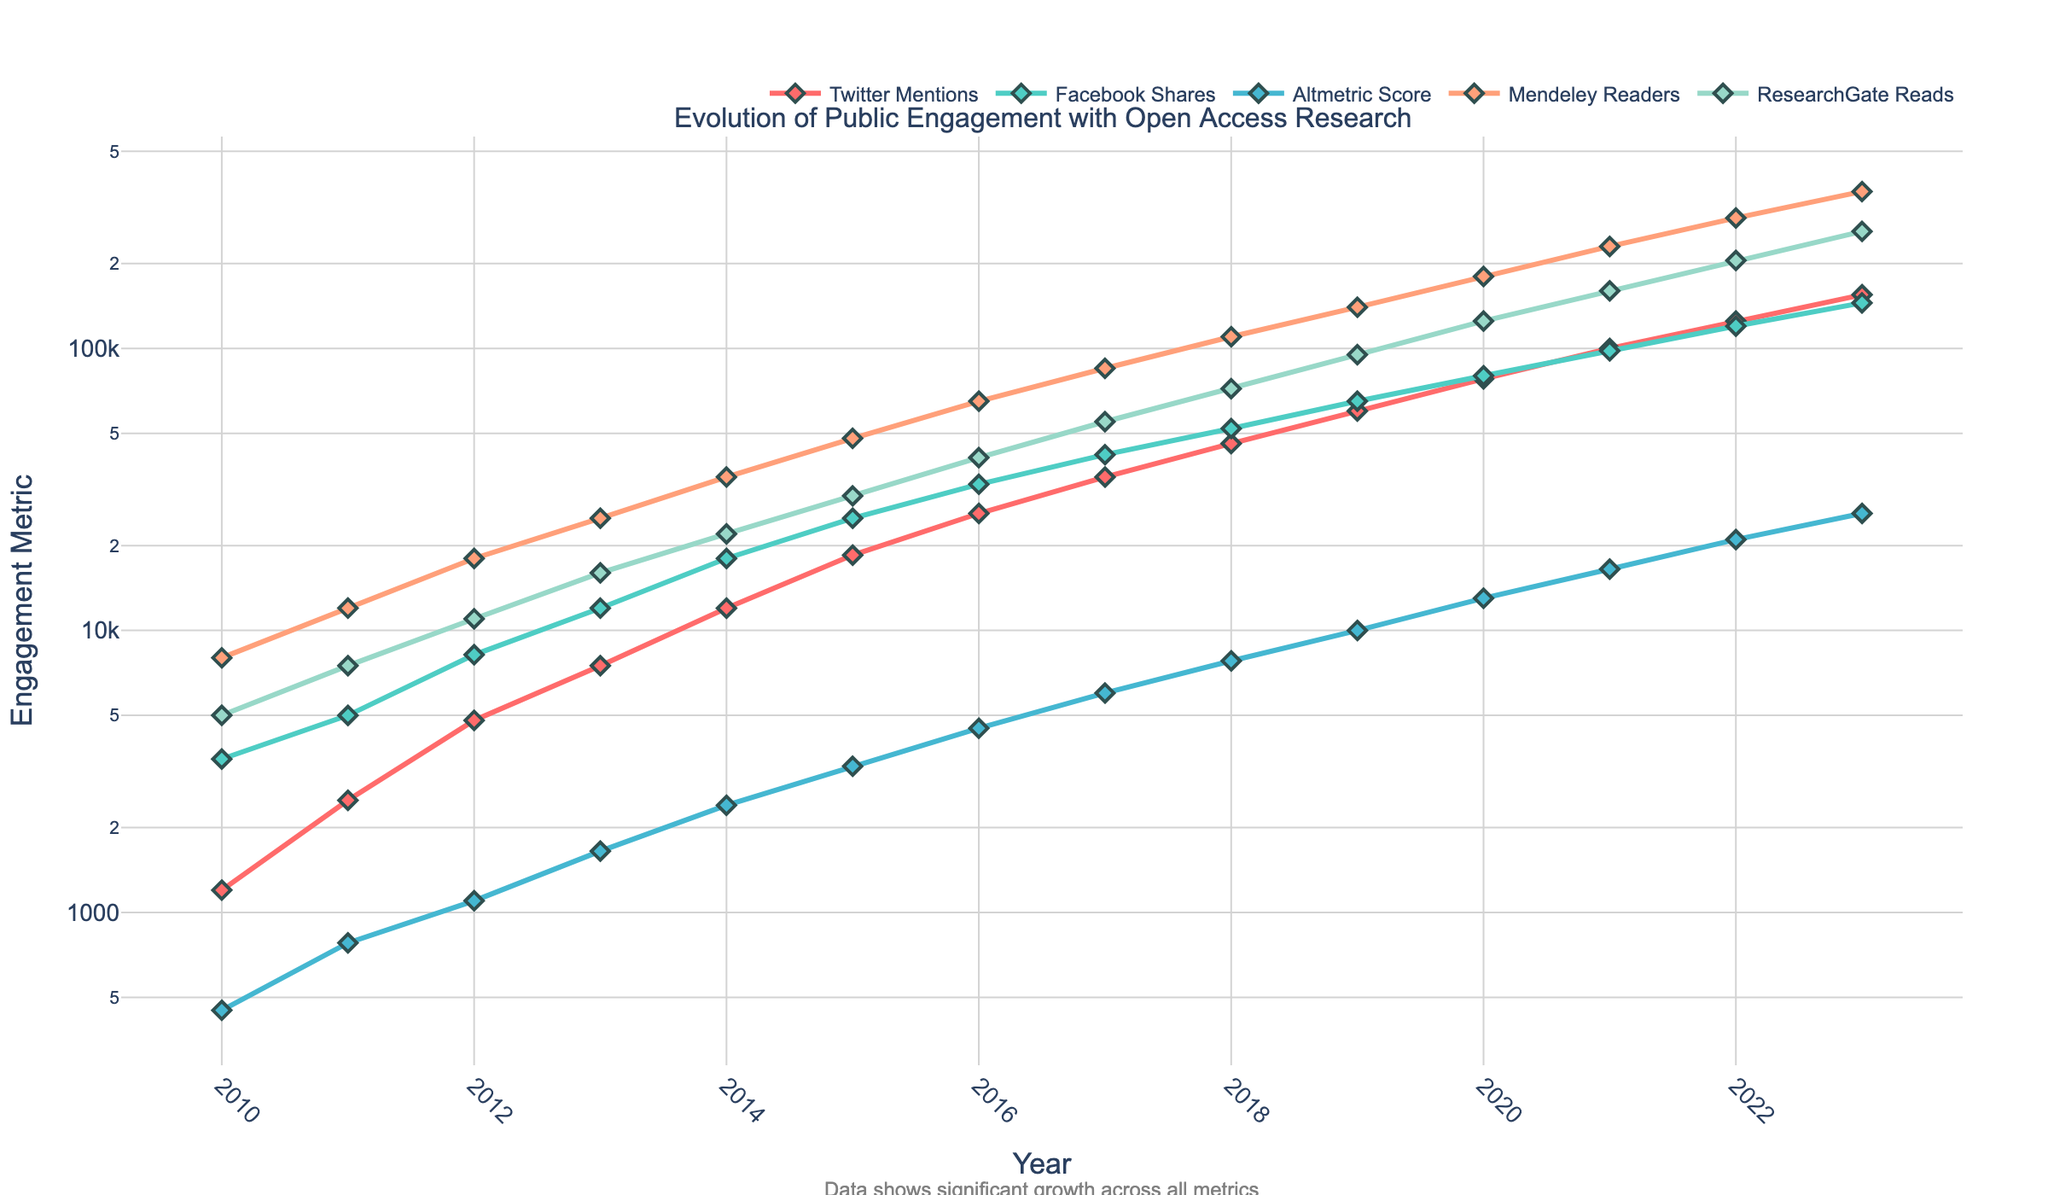What was the change in the number of Twitter mentions from 2010 to 2023? To find the change, subtract the number of Twitter mentions in 2010 from the number in 2023: 155,000 (2023) - 1,200 (2010) = 153,800
Answer: 153,800 Which platform saw the highest increase in engagement from 2010 to 2023? Examine the data for each platform's first and last year to determine the highest increase. For Twitter mentions: 155,000 - 1,200 = 153,800; For Facebook shares: 145,000 - 3,500 = 141,500; For Altmetric score: 26,000 - 450 = 25,550; For Mendeley readers: 360,000 - 8,000 = 352,000; For ResearchGate reads: 260,000 - 5,000 = 255,000. Hence, Mendeley readers saw the highest increase.
Answer: Mendeley readers Between which years did Altmetric scores show the most significant increase? To identify the steepest increase, look at the difference in Altmetric scores between consecutive years. The largest change occurred from 2022 to 2023: 26,000 (2023) - 21,000 (2022) = 5,000
Answer: 2022 to 2023 What is the average number of Facebook shares over the years? Sum all Facebook shares from 2010 to 2023 and divide by the number of years: (3,500 + 5,000 + 8,200 + 12,000 + 18,000 + 25,000 + 33,000 + 42,000 + 52,000 + 65,000 + 80,000 + 98,000 + 120,000 + 145,000) / 14 ≈ 49,485.71
Answer: 49,485.71 How does the trend of ResearchGate reads compare with Mendeley readers over the years? To compare the trends, observe the overall pattern and slope of the lines: both metrics show a consistent upward trend, but Mendeley readers increase at a significantly higher rate, especially from around 2014 onwards, where the curve steepens more than that of ResearchGate reads.
Answer: Mendeley readers increase faster than ResearchGate reads Which year did Twitter mentions surpass 10,000? Look at the Twitter mentions' line and identify the year when it crossed the 10,000 mark. It happened between 2012 and 2013 with 7,500 mentions in 2013, thus in 2014 it surpassed 10,000 with 12,000 mentions.
Answer: 2014 Compare the total engagement (sum of all metrics) in 2015 and 2020. Sum the values of each metric for the given years: For 2015: 18,500 + 25,000 + 3,300 + 48,000 + 30,000 = 124,800; For 2020: 78,000 + 80,000 + 13,000 + 180,000 + 125,000 = 476,000
Answer: 476,000 in 2020 is greater than 124,800 in 2015 Which engagement metric experienced the lowest growth from 2010 to 2023? Calculate the growth for each metric from 2010 to 2023. Twitter mentions: 153,800; Facebook shares: 141,500; Altmetric score: 25,550; Mendeley readers: 352,000; ResearchGate reads: 255,000. Thus, Altmetric score had the lowest growth.
Answer: Altmetric score How did the Altmetric score and Mendeley readers trend between 2015 and 2020? Examine the data from 2015 to 2020: Altmetric score went from 3,300 to 13,000, showing consistent growth; Mendeley readers increased from 48,000 to 180,000, showing a steep, upward trend. Both metrics show positive growth, though Mendeley readers grew at a significantly higher rate.
Answer: Both showed growth, but Mendeley readers grew much faster 